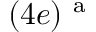<formula> <loc_0><loc_0><loc_500><loc_500>( 4 e ) ^ { a }</formula> 